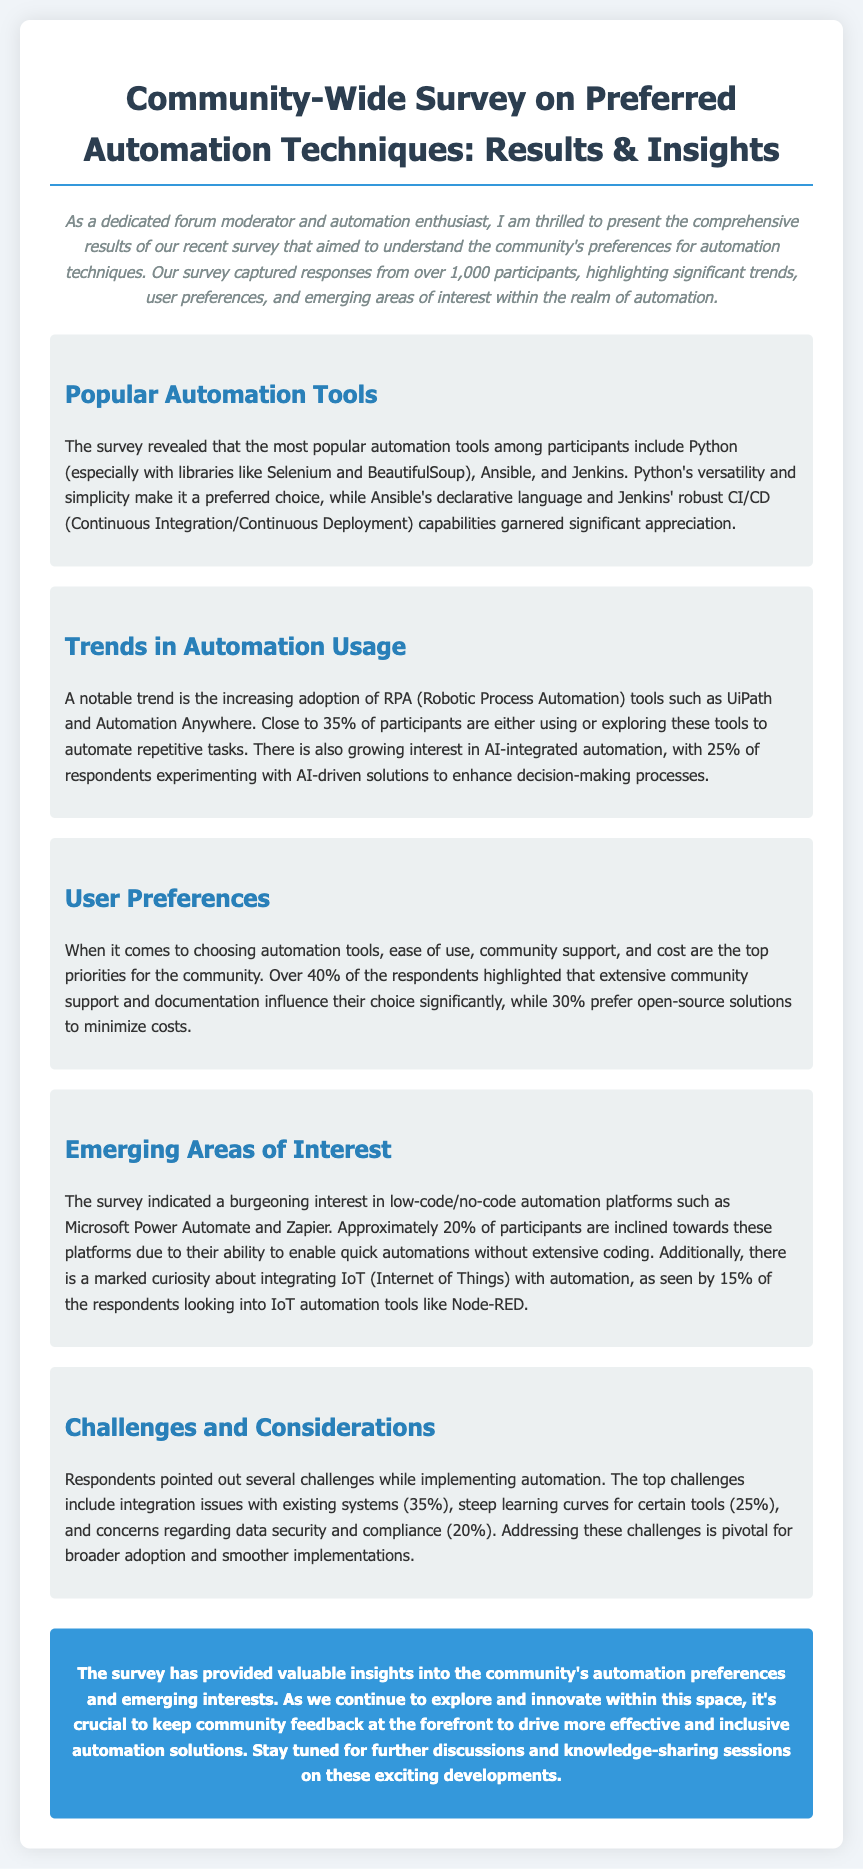What are the most popular automation tools mentioned? The document states that the most popular automation tools include Python, Ansible, and Jenkins.
Answer: Python, Ansible, and Jenkins What percentage of participants are using or exploring RPA tools? According to the results, close to 35% of participants are using or exploring RPA tools.
Answer: 35% What is the top priority for users when choosing automation tools? The document highlights that ease of use, community support, and cost are the top priorities for the community.
Answer: Ease of use, community support, and cost What emerging area of interest does the survey indicate regarding platforms? The survey indicates a growing interest in low-code/no-code automation platforms.
Answer: Low-code/no-code automation platforms What challenge is faced by 35% of respondents regarding automation implementation? The document mentions that integration issues with existing systems are the top challenge faced by respondents.
Answer: Integration issues with existing systems How many participants are looking into IoT automation tools? The survey shows that 15% of respondents are looking into IoT automation tools.
Answer: 15% What is the conclusion about community feedback? The document concludes that community feedback should drive more effective and inclusive automation solutions.
Answer: Community feedback should drive automation solutions 